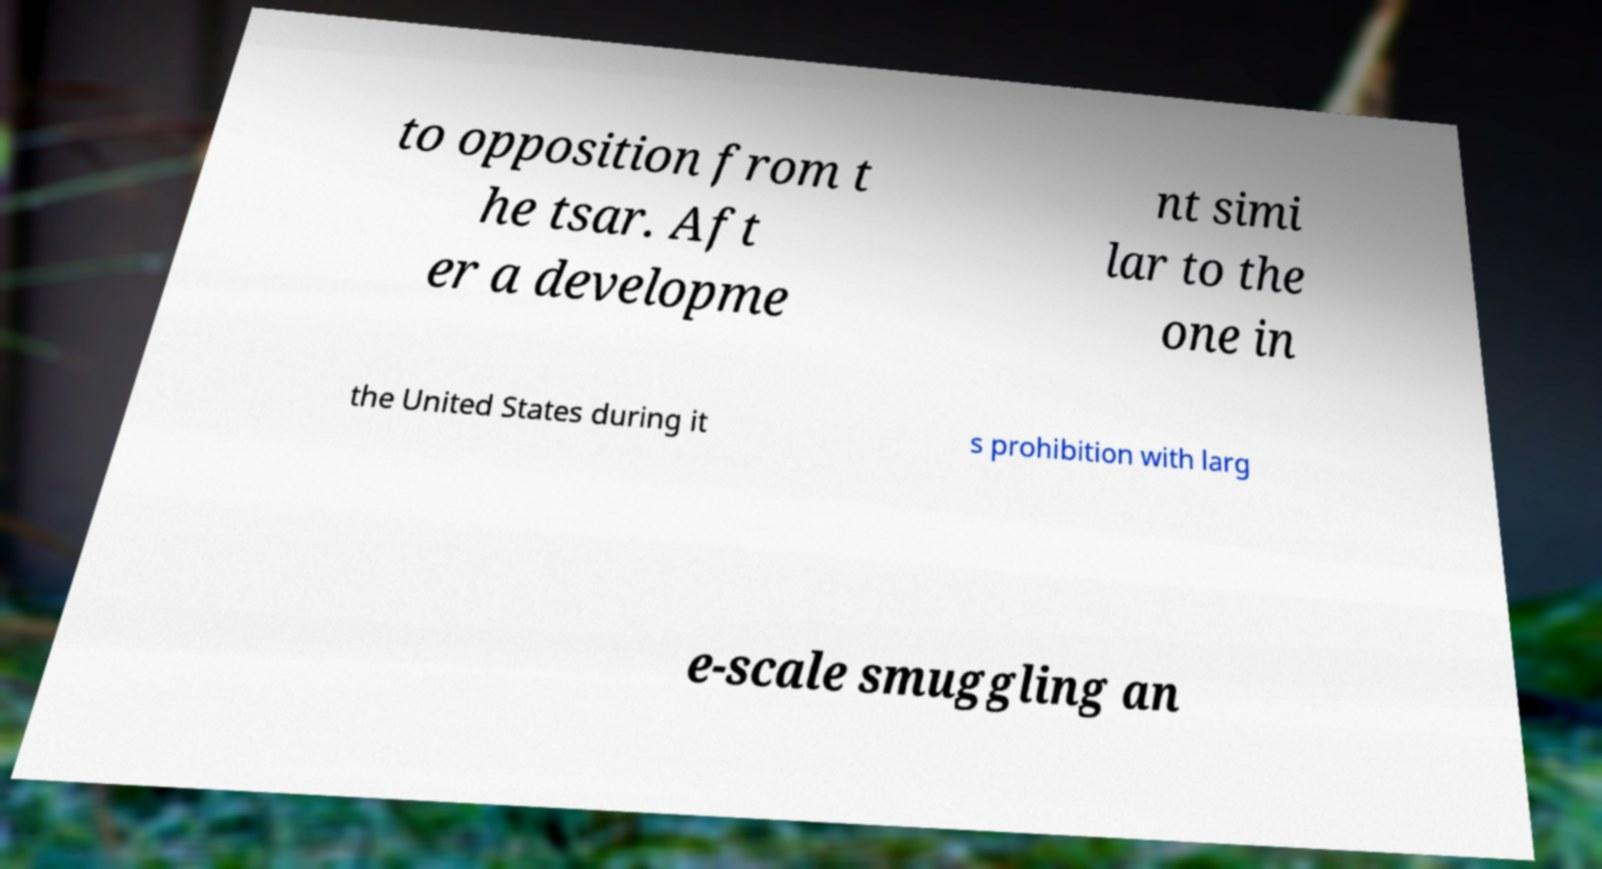For documentation purposes, I need the text within this image transcribed. Could you provide that? to opposition from t he tsar. Aft er a developme nt simi lar to the one in the United States during it s prohibition with larg e-scale smuggling an 